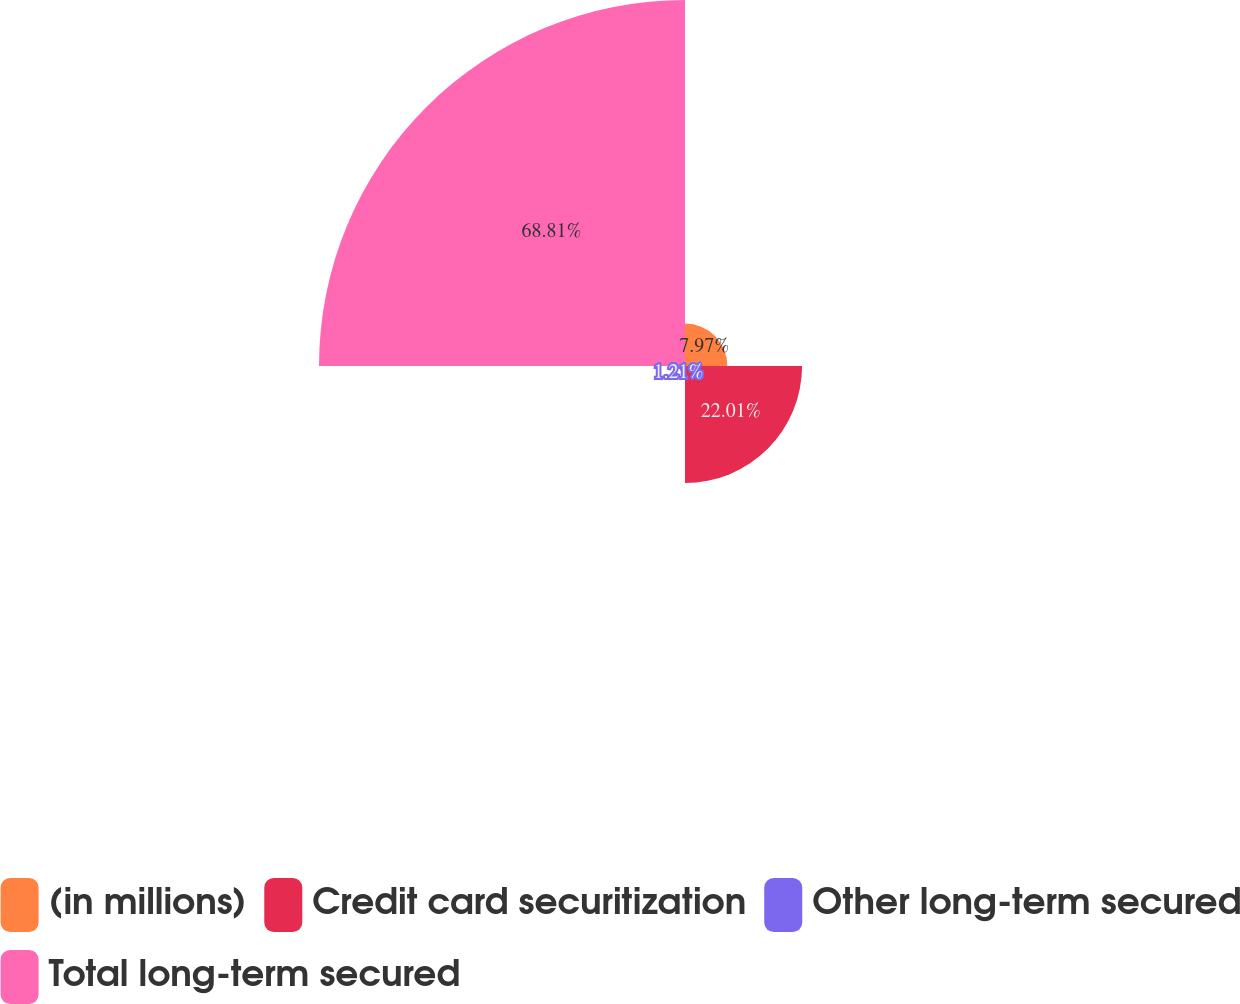Convert chart to OTSL. <chart><loc_0><loc_0><loc_500><loc_500><pie_chart><fcel>(in millions)<fcel>Credit card securitization<fcel>Other long-term secured<fcel>Total long-term secured<nl><fcel>7.97%<fcel>22.01%<fcel>1.21%<fcel>68.81%<nl></chart> 